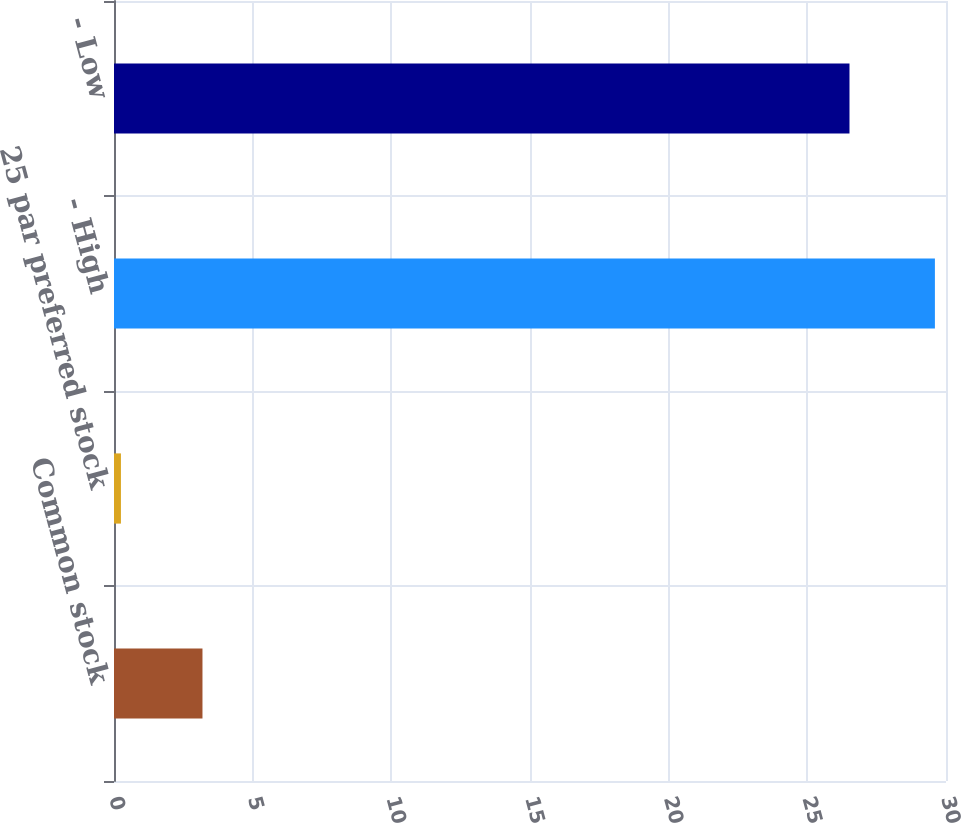<chart> <loc_0><loc_0><loc_500><loc_500><bar_chart><fcel>Common stock<fcel>25 par preferred stock<fcel>- High<fcel>- Low<nl><fcel>3.19<fcel>0.25<fcel>29.6<fcel>26.52<nl></chart> 